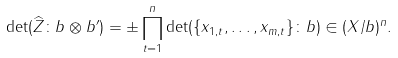Convert formula to latex. <formula><loc_0><loc_0><loc_500><loc_500>\det ( \widehat { Z } \colon b \otimes b ^ { \prime } ) = \pm \prod _ { t = 1 } ^ { n } \det ( \{ x _ { 1 , t } , \dots , x _ { m , t } \} \colon b ) \in ( X / b ) ^ { n } .</formula> 